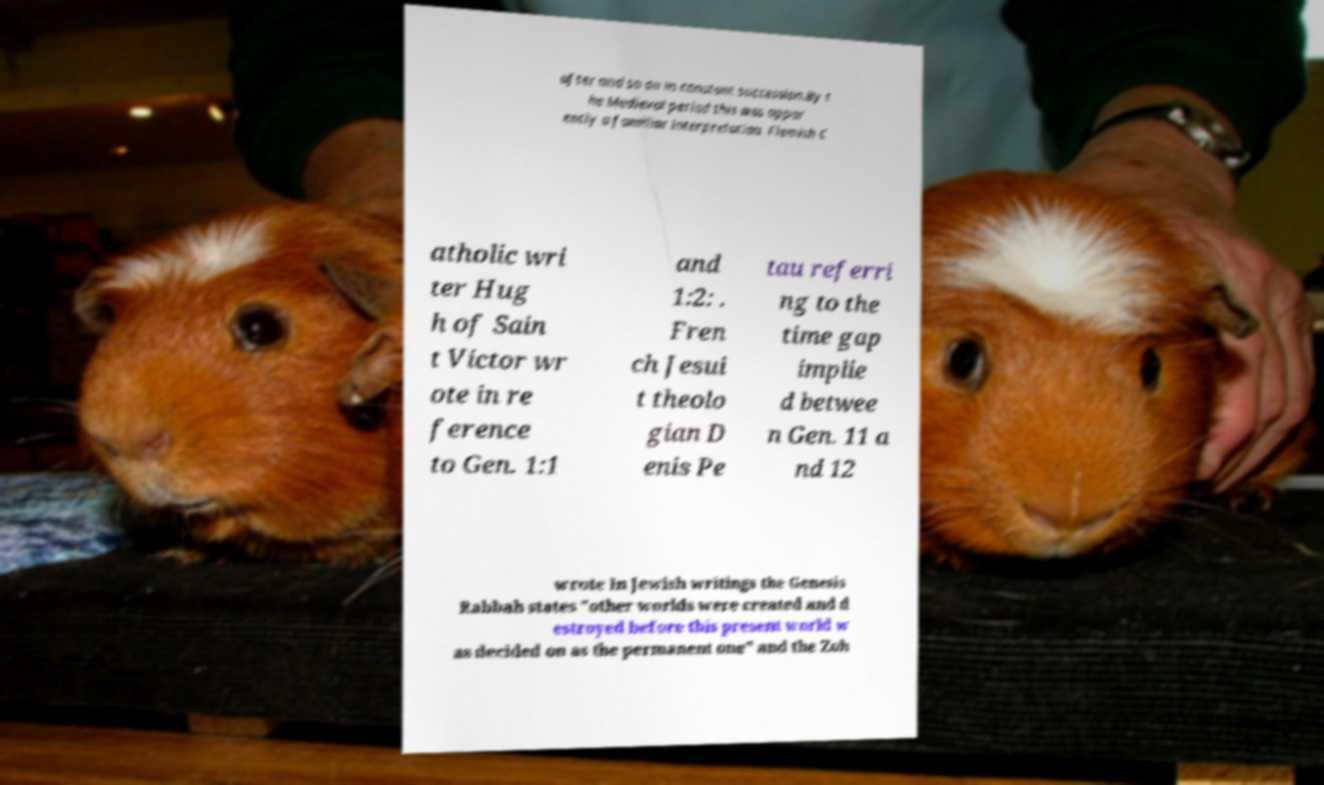Please identify and transcribe the text found in this image. after and so on in constant succession.By t he Medieval period this was appar ently a familiar interpretation. Flemish C atholic wri ter Hug h of Sain t Victor wr ote in re ference to Gen. 1:1 and 1:2: . Fren ch Jesui t theolo gian D enis Pe tau referri ng to the time gap implie d betwee n Gen. 11 a nd 12 wrote In Jewish writings the Genesis Rabbah states "other worlds were created and d estroyed before this present world w as decided on as the permanent one" and the Zoh 